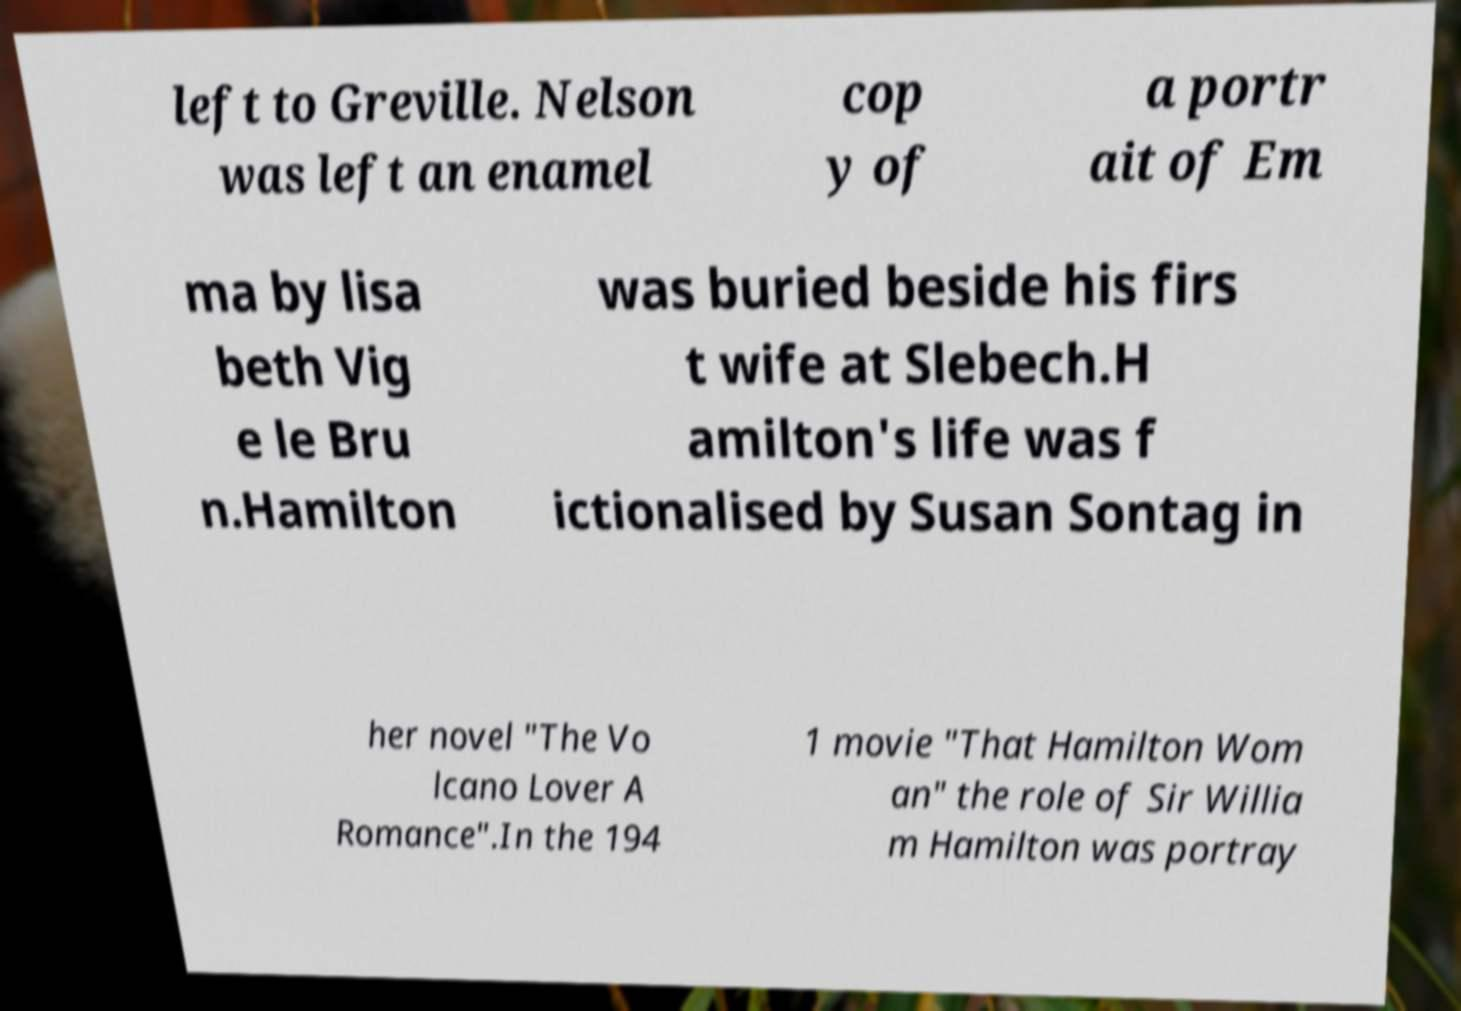For documentation purposes, I need the text within this image transcribed. Could you provide that? left to Greville. Nelson was left an enamel cop y of a portr ait of Em ma by lisa beth Vig e le Bru n.Hamilton was buried beside his firs t wife at Slebech.H amilton's life was f ictionalised by Susan Sontag in her novel "The Vo lcano Lover A Romance".In the 194 1 movie "That Hamilton Wom an" the role of Sir Willia m Hamilton was portray 